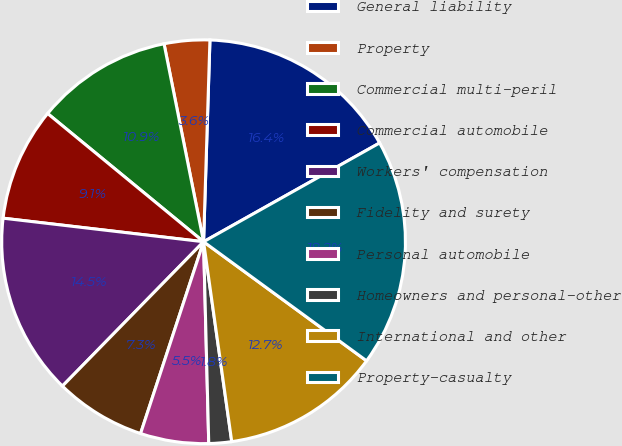Convert chart to OTSL. <chart><loc_0><loc_0><loc_500><loc_500><pie_chart><fcel>General liability<fcel>Property<fcel>Commercial multi-peril<fcel>Commercial automobile<fcel>Workers' compensation<fcel>Fidelity and surety<fcel>Personal automobile<fcel>Homeowners and personal-other<fcel>International and other<fcel>Property-casualty<nl><fcel>16.36%<fcel>3.64%<fcel>10.91%<fcel>9.09%<fcel>14.54%<fcel>7.27%<fcel>5.46%<fcel>1.82%<fcel>12.73%<fcel>18.18%<nl></chart> 